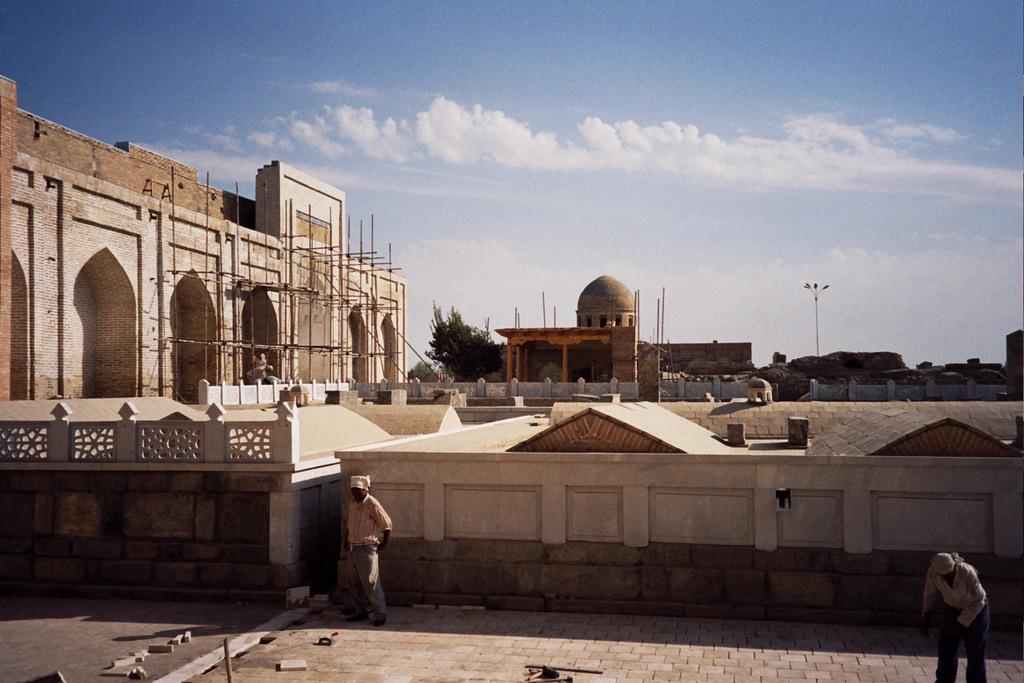How would you summarize this image in a sentence or two? In this picture we can see buildings in the background, there are two persons standing in the front, at the bottom there are some bricks, we can also see a pole, lights and a tree in the background, on the left side there are some wooden sticks, there is the sky and clouds at the top of the picture. 